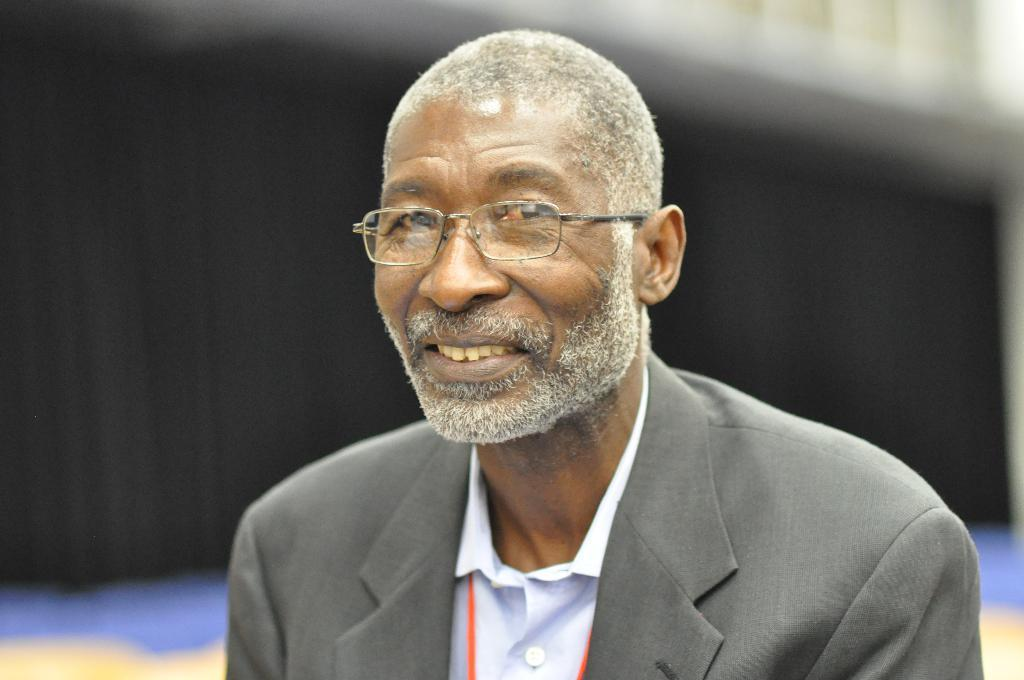What can be seen in the image? There is a person in the image. Can you describe the person's appearance? The person is wearing spectacles. What is visible in the background of the image? There is a curtain in the background of the image. What type of crime is being committed by the person's knee in the image? There is no mention of a knee or any crime in the image. The image only shows a person wearing spectacles with a curtain in the background. 